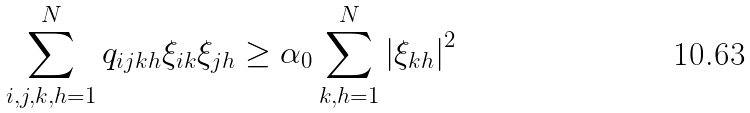<formula> <loc_0><loc_0><loc_500><loc_500>\sum _ { i , j , k , h = 1 } ^ { N } q _ { i j k h } \xi _ { i k } \xi _ { j h } \geq \alpha _ { 0 } \sum _ { k , h = 1 } ^ { N } \left | \xi _ { k h } \right | ^ { 2 }</formula> 